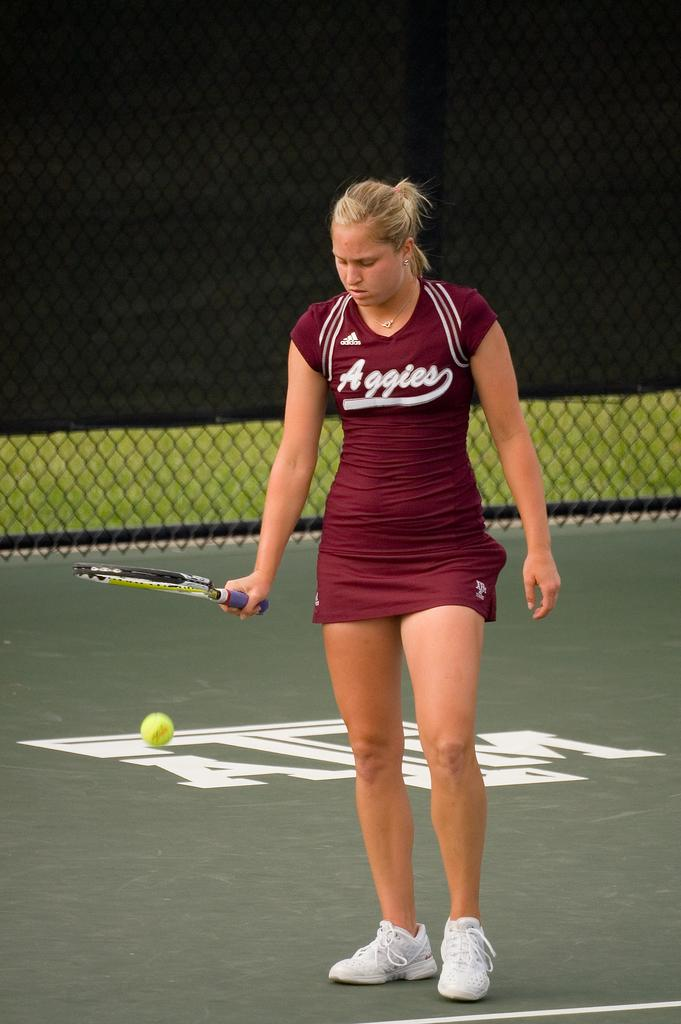Who is present in the image? There is a woman in the image. What is the woman doing in the image? The woman is standing and holding a racket. What type of footwear is the woman wearing? The woman is wearing shoes. What can be seen in the background of the image? There is a net in the background of the image. What object is on the floor in the image? There is a ball on the floor in the image. What type of doll is sitting on the committee in the image? There is no doll or committee present in the image. 